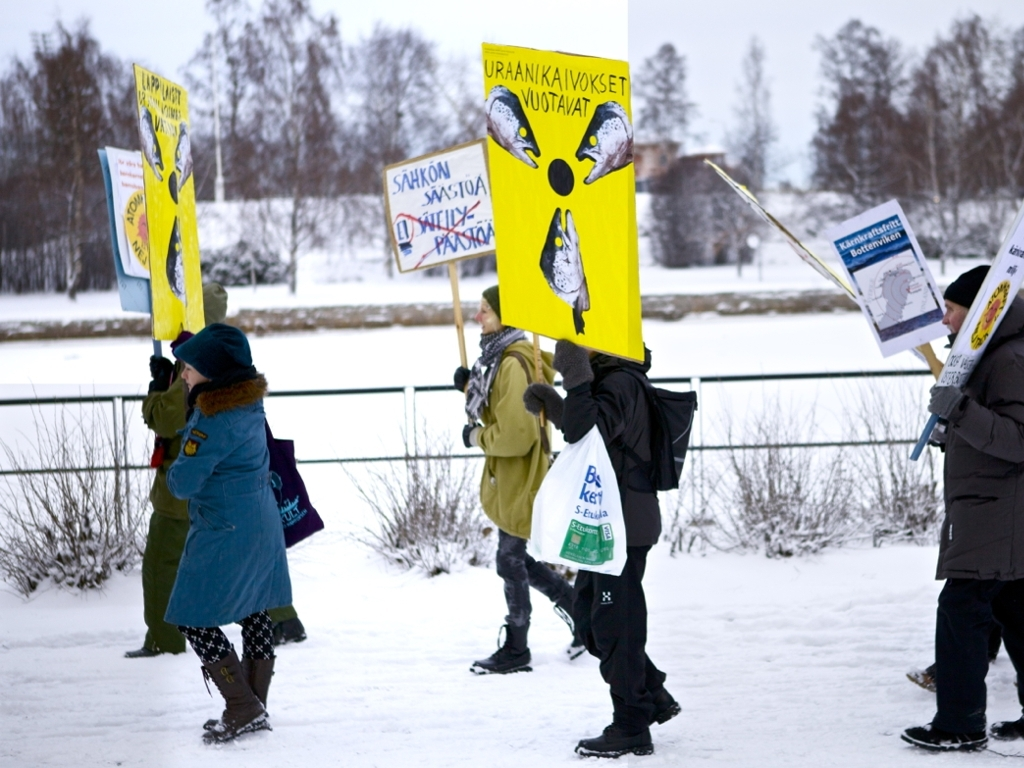Can you describe the weather conditions and how they might affect this event? The weather looks cold and snowy, with overcast skies that hint at the possibility of more snowfall. Despite these challenging conditions, the participants are dressed appropriately for the cold, which suggests that they are prepared and determined. The weather does not seem to be deterring them, instead, it potentially emphasizes the urgency and importance of their cause. The snowy setting could even serve to highlight the visual impact of their colorful signs. 